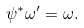<formula> <loc_0><loc_0><loc_500><loc_500>\psi ^ { * } \omega ^ { \prime } = \omega .</formula> 